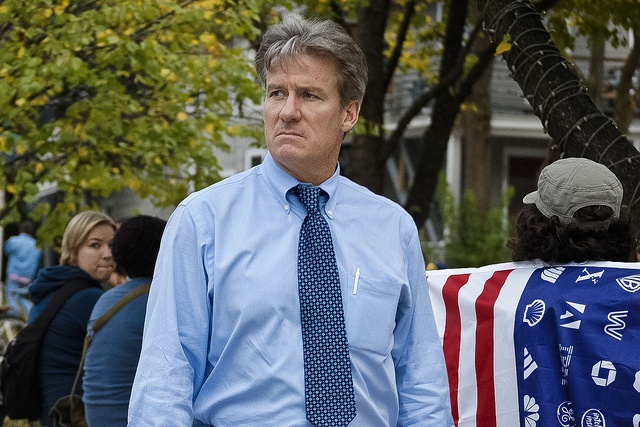Describe the objects in this image and their specific colors. I can see people in black, darkgray, lightblue, and gray tones, people in black and gray tones, people in black, gray, and darkgray tones, people in black, navy, blue, and gray tones, and tie in black, navy, lightblue, and gray tones in this image. 